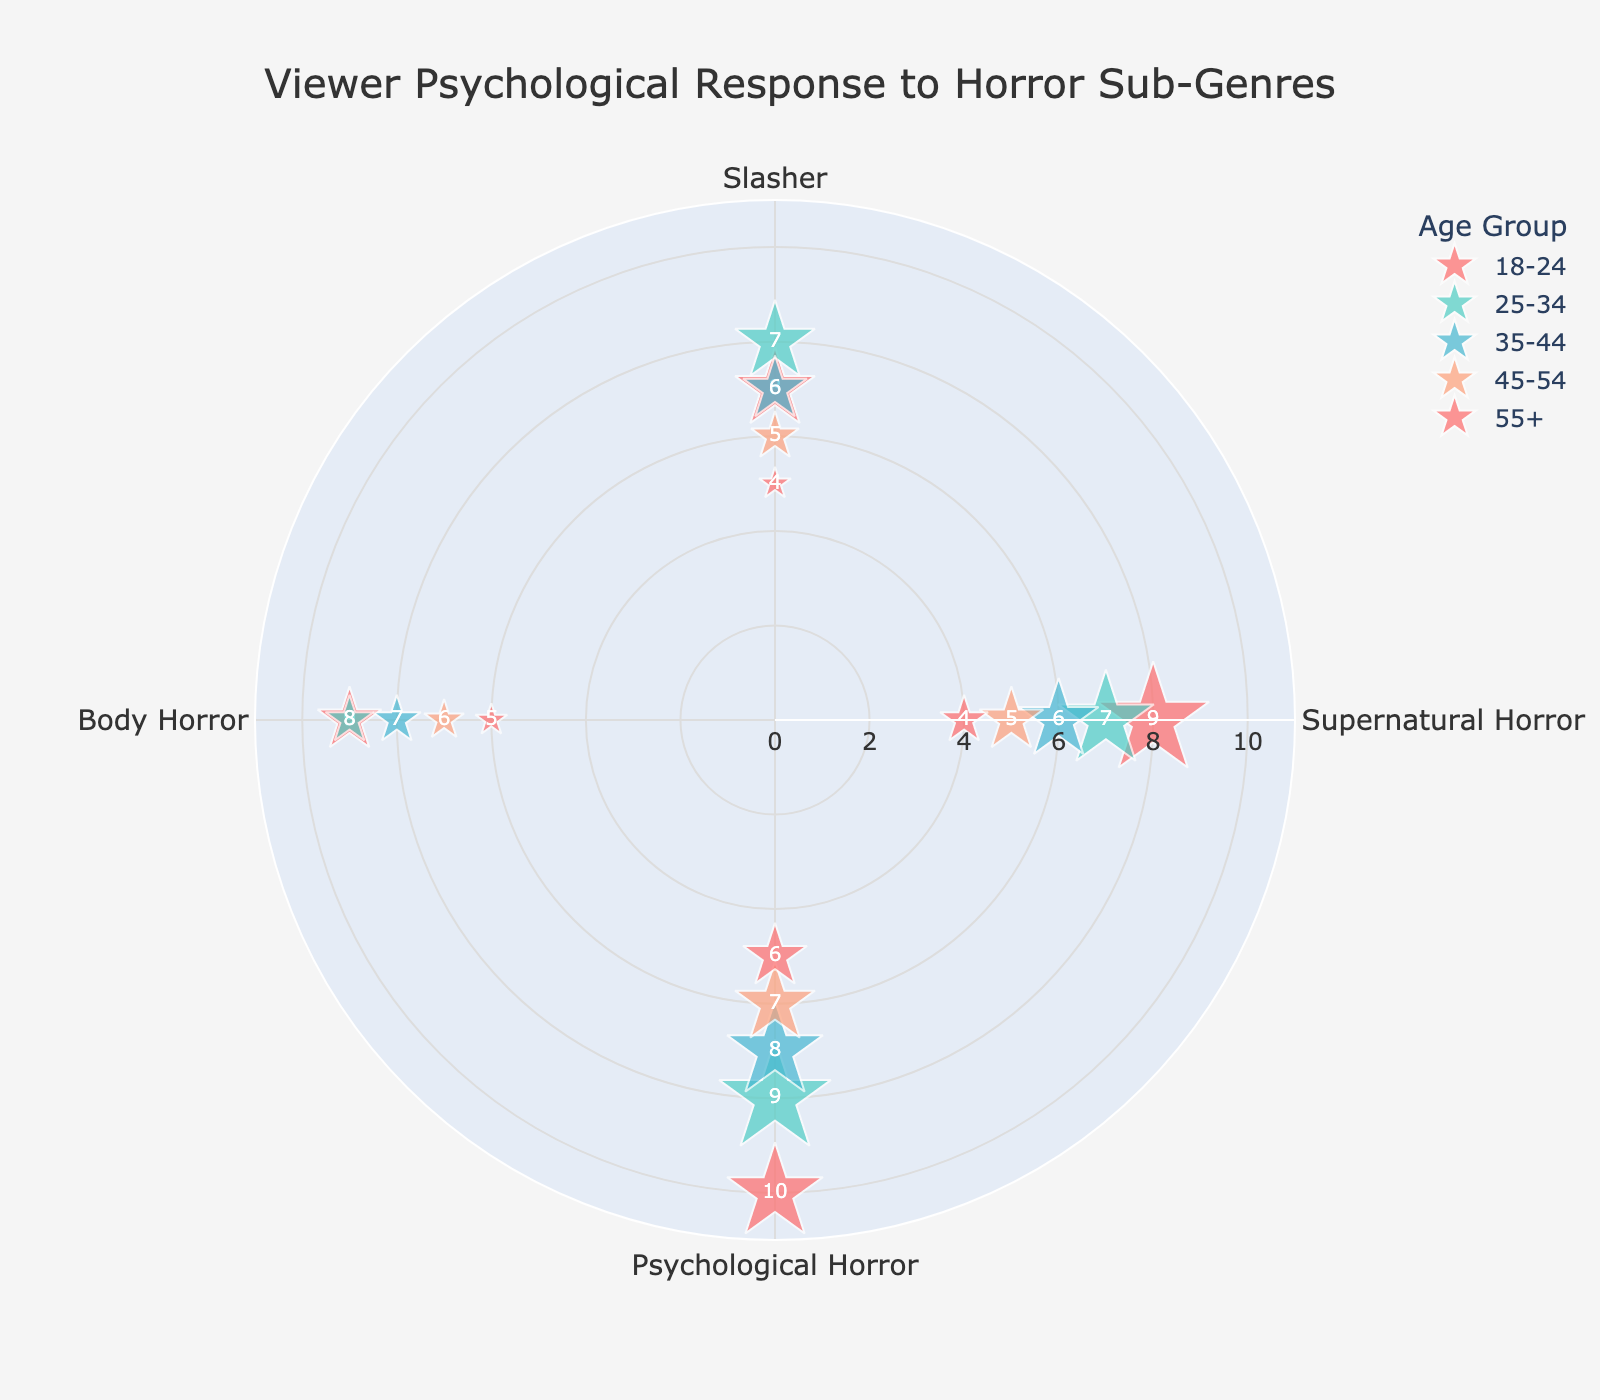What's the title of the chart? The title of the chart is typically displayed prominently at the top in a clear and readable font.
Answer: Viewer Psychological Response to Horror Sub-Genres How many age groups are represented in the chart? The number of age groups can be determined by counting the distinct groups shown in the legend or directly on the plot.
Answer: 5 Which sub-genre shows the highest intensity within the 18-24 age group? Look for the data points corresponding to the 18-24 age group and identify the sub-genre with the highest radial value.
Answer: Psychological Horror What's the color associated with the 25-34 age group? Colors are used to distinguish different age groups, referenced in the scatterplot markers or legend.
Answer: Light green (#4ECDC4) Which age group has the least frequency for Supernatural Horror? Check the marker sizes associated with Supernatural Horror across all age groups and identify the smallest size.
Answer: 55+ In the 35-44 age group, which sub-genre has a higher impact, Psychological Horror or Slasher? Compare the impact text values displayed at the markers corresponding to Psychological Horror and Slasher within the 35-44 age group.
Answer: Psychological Horror What is the frequency for Body Horror in the 18-24 age group? Check the size of the marker for Body Horror in the 18-24 age group; since sizes directly relate to frequency, divide the size of the marker by 3 (based on code insight).
Answer: 8 Which age group experiences greater impact from Supernatural Horror compared to Body Horror? Compare the impact values for Supernatural Horror and Body Horror across all age groups and identify where Supernatural Horror is greater.
Answer: None (No age group experiences Supernatural Horror with a higher impact than Body Horror) For the 45-54 age group, calculate the average intensity across all sub-genres. Sum the intensity values for all sub-genres in the 45-54 age group and divide by the number of sub-genres. (5 + 6 + 7 + 6) / 4 = 24 / 4 = 6
Answer: 6 How does the impact of Body Horror in the 55+ age group compare to the impact of Psychological Horror in the same age group? Check and compare the impact values for Body Horror and Psychological Horror within the 55+ age group specifically.
Answer: Psychological Horror impact is higher than Body Horror 